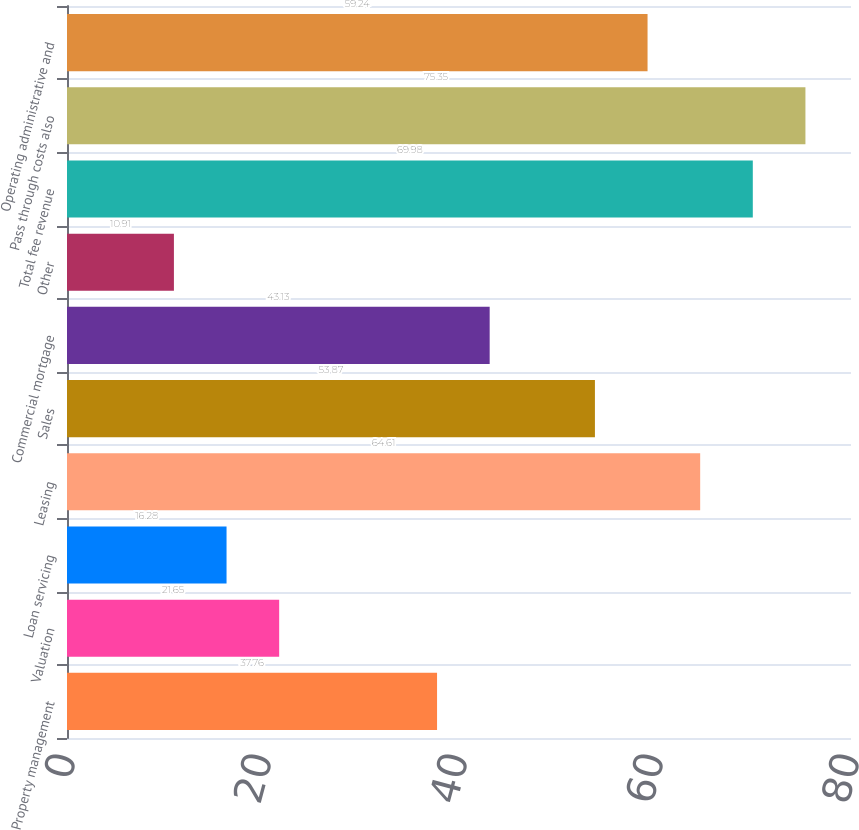Convert chart. <chart><loc_0><loc_0><loc_500><loc_500><bar_chart><fcel>Property management<fcel>Valuation<fcel>Loan servicing<fcel>Leasing<fcel>Sales<fcel>Commercial mortgage<fcel>Other<fcel>Total fee revenue<fcel>Pass through costs also<fcel>Operating administrative and<nl><fcel>37.76<fcel>21.65<fcel>16.28<fcel>64.61<fcel>53.87<fcel>43.13<fcel>10.91<fcel>69.98<fcel>75.35<fcel>59.24<nl></chart> 